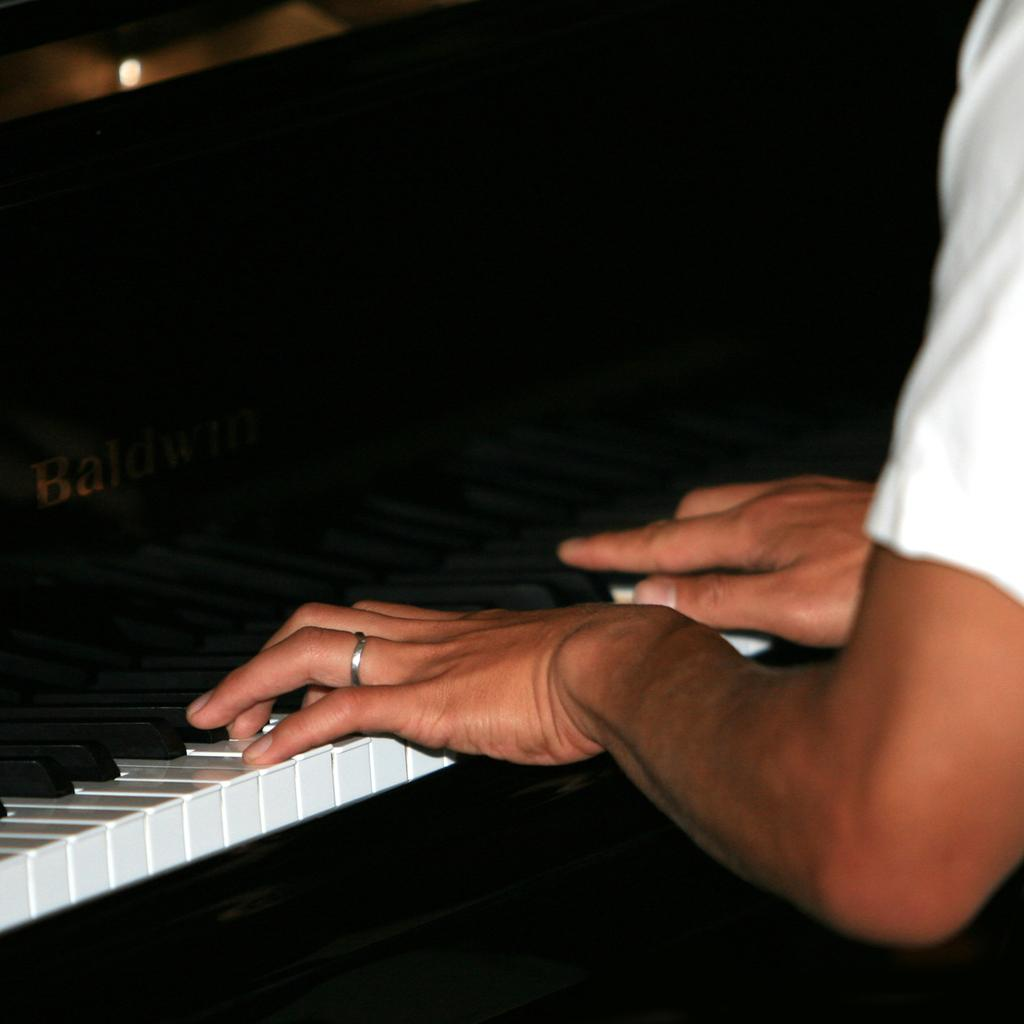What is the main activity being performed in the image? There is a person playing the piano in the image. Can you describe the lighting in the image? There is a light at the top of the image. Is there any text visible in the image? Yes, the name of the person or the piece being played is visible on the left side of the image. Can you see any pancakes being flipped in the image? No, there are no pancakes or any indication of pancake-flipping in the image. Is there an ocean visible in the background of the image? No, there is no ocean or any body of water visible in the image. 